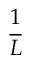Convert formula to latex. <formula><loc_0><loc_0><loc_500><loc_500>\frac { 1 } { L }</formula> 